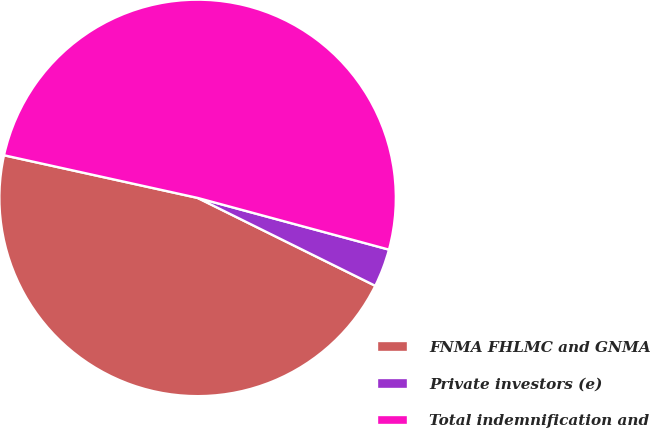Convert chart to OTSL. <chart><loc_0><loc_0><loc_500><loc_500><pie_chart><fcel>FNMA FHLMC and GNMA<fcel>Private investors (e)<fcel>Total indemnification and<nl><fcel>46.14%<fcel>3.11%<fcel>50.75%<nl></chart> 